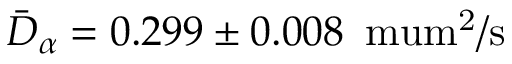<formula> <loc_0><loc_0><loc_500><loc_500>\bar { D } _ { \alpha } = 0 . 2 9 9 \pm 0 . 0 0 8 \, { \ m u m ^ { 2 } / s }</formula> 